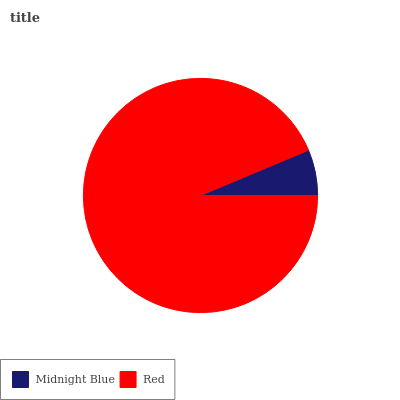Is Midnight Blue the minimum?
Answer yes or no. Yes. Is Red the maximum?
Answer yes or no. Yes. Is Red the minimum?
Answer yes or no. No. Is Red greater than Midnight Blue?
Answer yes or no. Yes. Is Midnight Blue less than Red?
Answer yes or no. Yes. Is Midnight Blue greater than Red?
Answer yes or no. No. Is Red less than Midnight Blue?
Answer yes or no. No. Is Red the high median?
Answer yes or no. Yes. Is Midnight Blue the low median?
Answer yes or no. Yes. Is Midnight Blue the high median?
Answer yes or no. No. Is Red the low median?
Answer yes or no. No. 